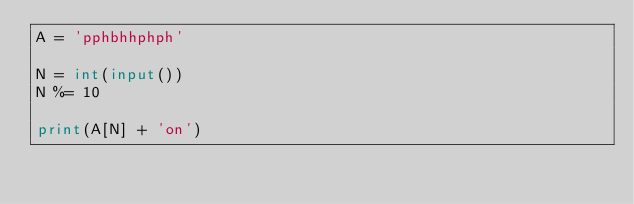<code> <loc_0><loc_0><loc_500><loc_500><_Python_>A = 'pphbhhphph'

N = int(input())
N %= 10

print(A[N] + 'on')
</code> 